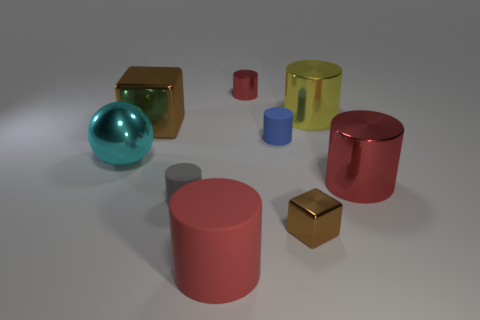Is there a ball that has the same size as the yellow cylinder?
Your answer should be compact. Yes. What is the material of the small red object that is the same shape as the yellow object?
Keep it short and to the point. Metal. The yellow shiny thing that is the same size as the cyan shiny ball is what shape?
Ensure brevity in your answer.  Cylinder. Are there any brown matte things that have the same shape as the small gray object?
Provide a succinct answer. No. There is a small rubber object behind the gray matte cylinder that is on the left side of the small blue cylinder; what is its shape?
Your response must be concise. Cylinder. There is a gray matte thing; what shape is it?
Offer a very short reply. Cylinder. What is the material of the cylinder in front of the brown block in front of the small blue object that is in front of the large yellow metallic cylinder?
Make the answer very short. Rubber. What number of other things are made of the same material as the tiny gray cylinder?
Your response must be concise. 2. How many big yellow metal cylinders are to the left of the tiny gray cylinder that is to the right of the big brown metallic block?
Provide a short and direct response. 0. How many balls are small gray objects or big cyan metal objects?
Give a very brief answer. 1. 